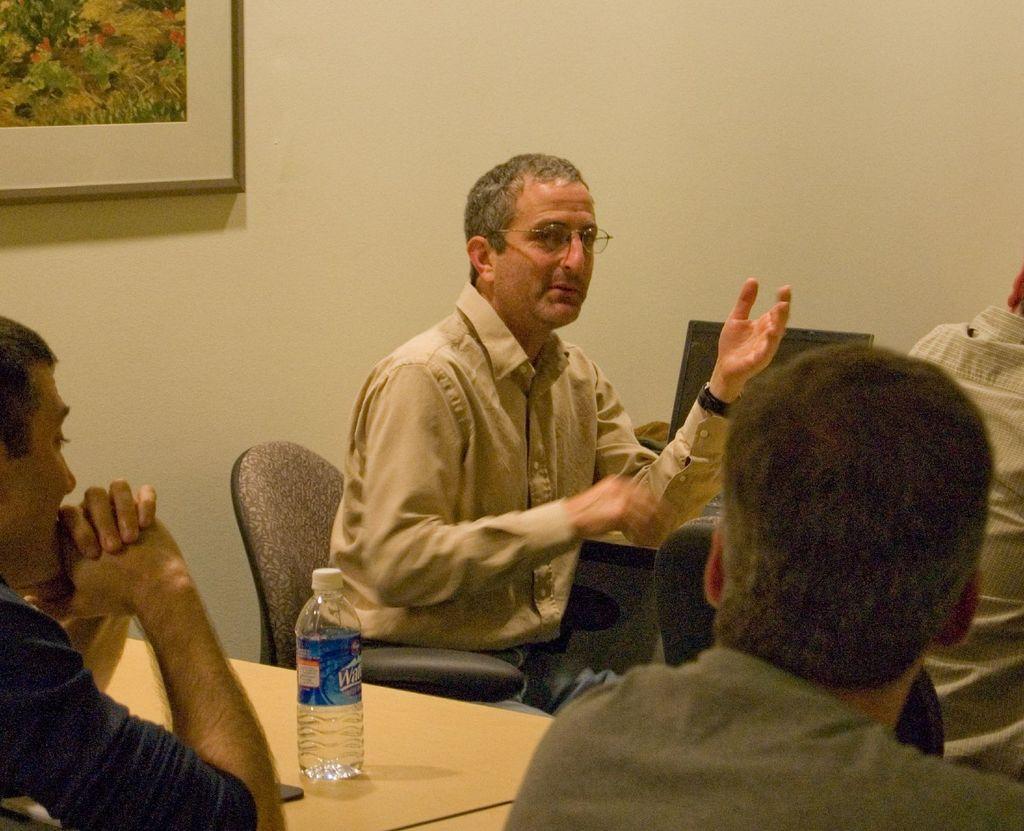In one or two sentences, can you explain what this image depicts? There is a man in the picture, sitting in the chair in front of a table on which a computer is placed. There are other two members sitting in front of him. On the table water bottle is placed. In the background there is a photo frame attached to the wall. 